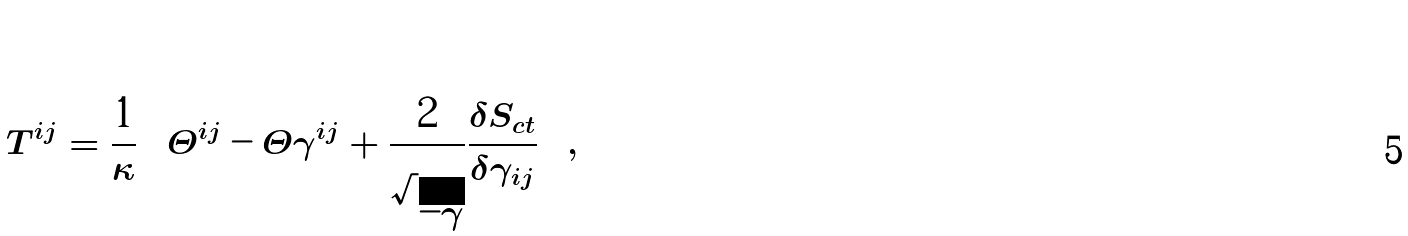Convert formula to latex. <formula><loc_0><loc_0><loc_500><loc_500>T ^ { i j } = \frac { 1 } { \kappa } \left [ \Theta ^ { i j } - \Theta \gamma ^ { i j } + \frac { 2 } { \sqrt { - \gamma } } \frac { \delta S _ { c t } } { \delta \gamma _ { i j } } \right ] ,</formula> 